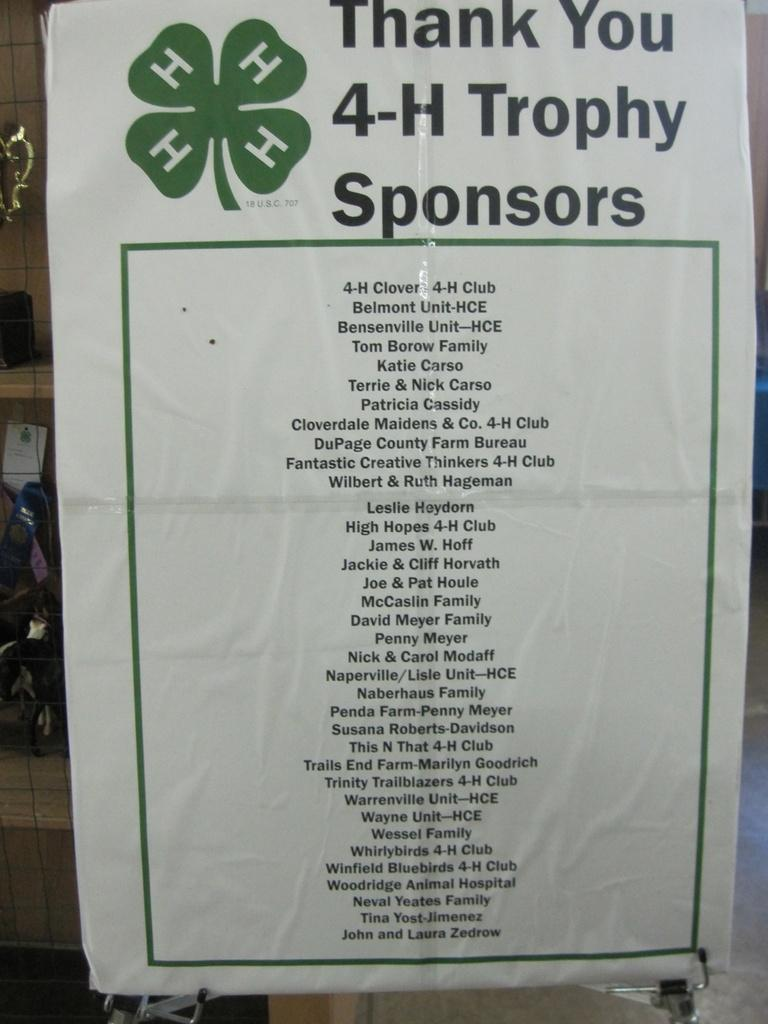<image>
Give a short and clear explanation of the subsequent image. A white piece of paper contains a long list of names that belong to 4-H Trophy Sponsors. 